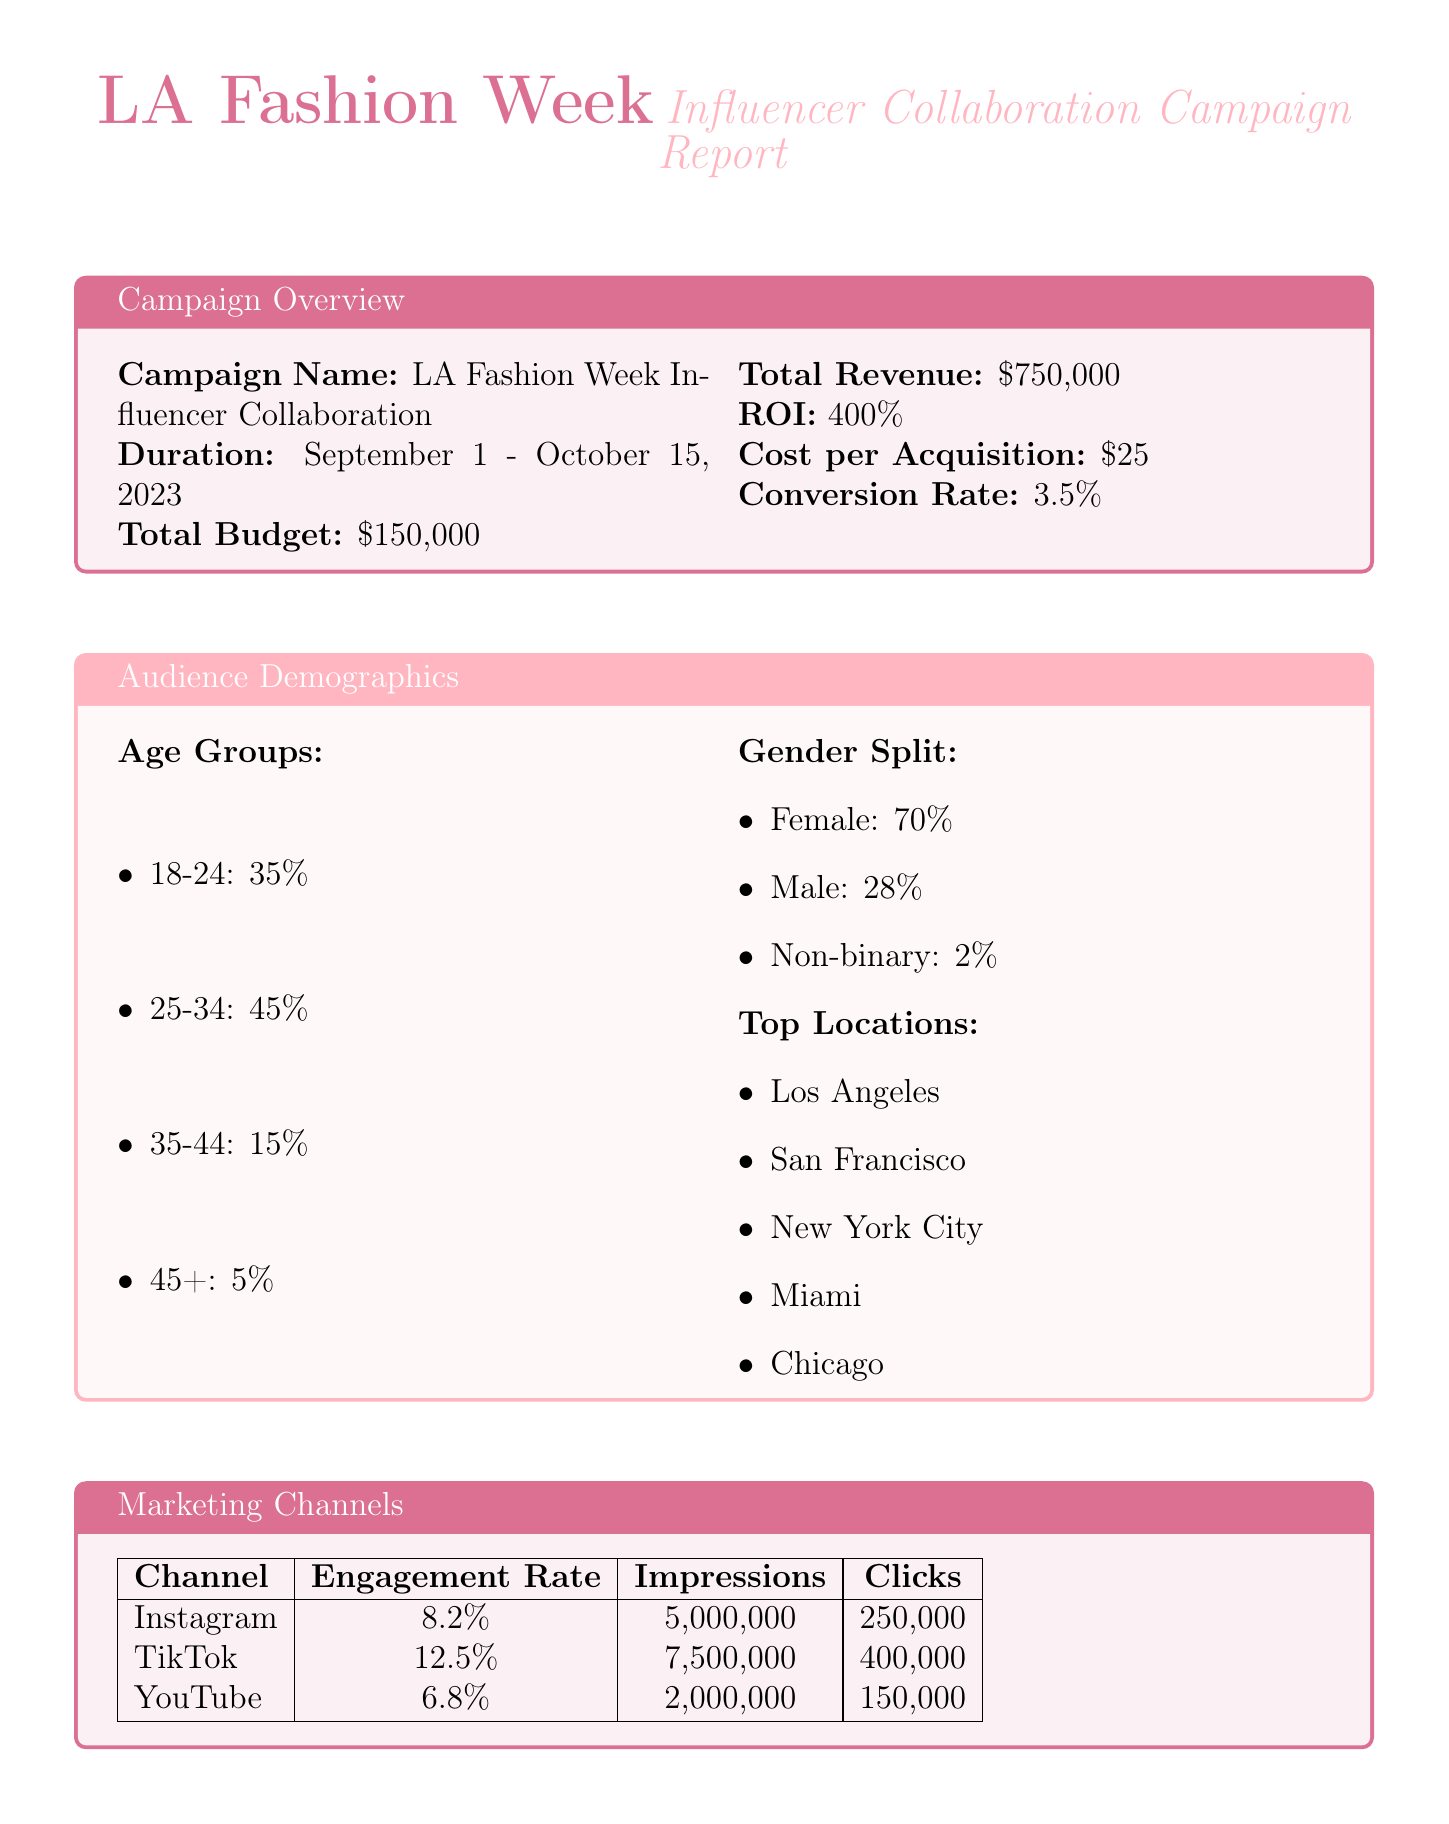What is the campaign name? The campaign name is specified at the beginning of the report as LA Fashion Week Influencer Collaboration.
Answer: LA Fashion Week Influencer Collaboration What is the total budget for the campaign? The total budget is clearly stated in the overview section of the report as $150,000.
Answer: $150,000 What is the return on investment (ROI)? The ROI is a metric presented in the ROI metrics section, which is 400%.
Answer: 400% What percentage of the audience is aged 25-34? The audience demographics section provides the percentage for the age group 25-34, which is 45%.
Answer: 45% Which marketing channel had the highest engagement rate? By comparing the engagement rates listed for each marketing channel, TikTok has the highest engagement rate at 12.5%.
Answer: TikTok Which influencer has the most followers? The top influencers section lists followers, showing that Addison Rae has the most followers, with 88 million.
Answer: 88 million What product generated the highest revenue? In the product performance section, it's noted that the LA Sunset Collection Eyeshadow Palette generated the highest revenue, totaling $450,000.
Answer: LA Sunset Collection Eyeshadow Palette What is the average customer rating? The customer feedback section indicates the average rating as 4.7 out of 5.
Answer: 4.7/5 What was the key recommendation regarding influencer partnerships? The future recommendations section includes a suggestion to expand influencer partnerships to include micro-influencers in niche LA fashion markets.
Answer: Expand influencer partnerships to include micro-influencers in niche LA fashion markets 